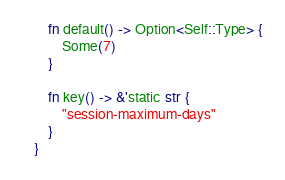<code> <loc_0><loc_0><loc_500><loc_500><_Rust_>    fn default() -> Option<Self::Type> {
        Some(7)
    }

    fn key() -> &'static str {
        "session-maximum-days"
    }
}
</code> 